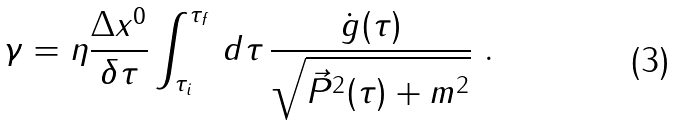<formula> <loc_0><loc_0><loc_500><loc_500>\gamma = \eta \frac { \Delta x ^ { 0 } } { \delta \tau } \int _ { \tau _ { i } } ^ { \tau _ { f } } \, d \tau \, \frac { \dot { g } ( \tau ) } { \sqrt { \vec { P } ^ { 2 } ( \tau ) + m ^ { 2 } } } \ .</formula> 